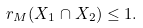<formula> <loc_0><loc_0><loc_500><loc_500>r _ { M } ( X _ { 1 } \cap X _ { 2 } ) \leq 1 .</formula> 